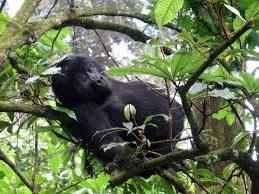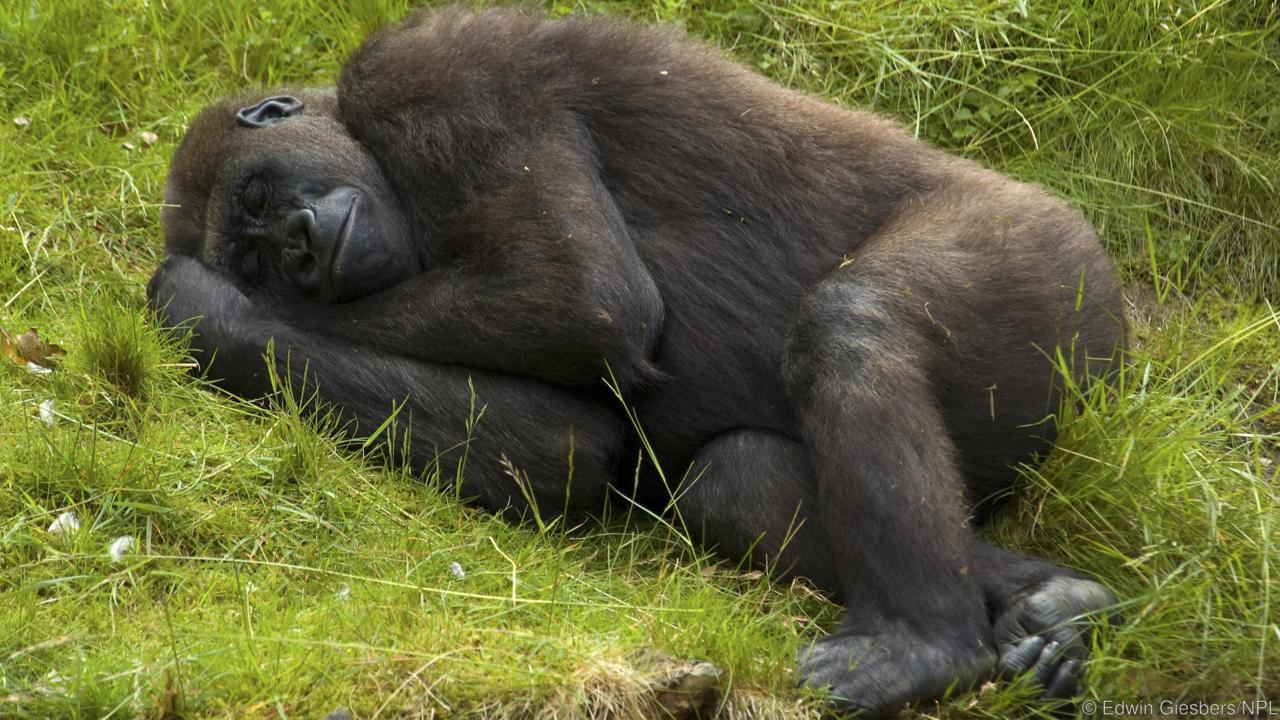The first image is the image on the left, the second image is the image on the right. Assess this claim about the two images: "There are two gorillas in the pair of images.". Correct or not? Answer yes or no. Yes. 